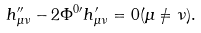Convert formula to latex. <formula><loc_0><loc_0><loc_500><loc_500>h _ { \mu \nu } ^ { \prime \prime } - 2 \Phi ^ { 0 \prime } h _ { \mu \nu } ^ { \prime } = 0 ( \mu \neq \nu ) .</formula> 